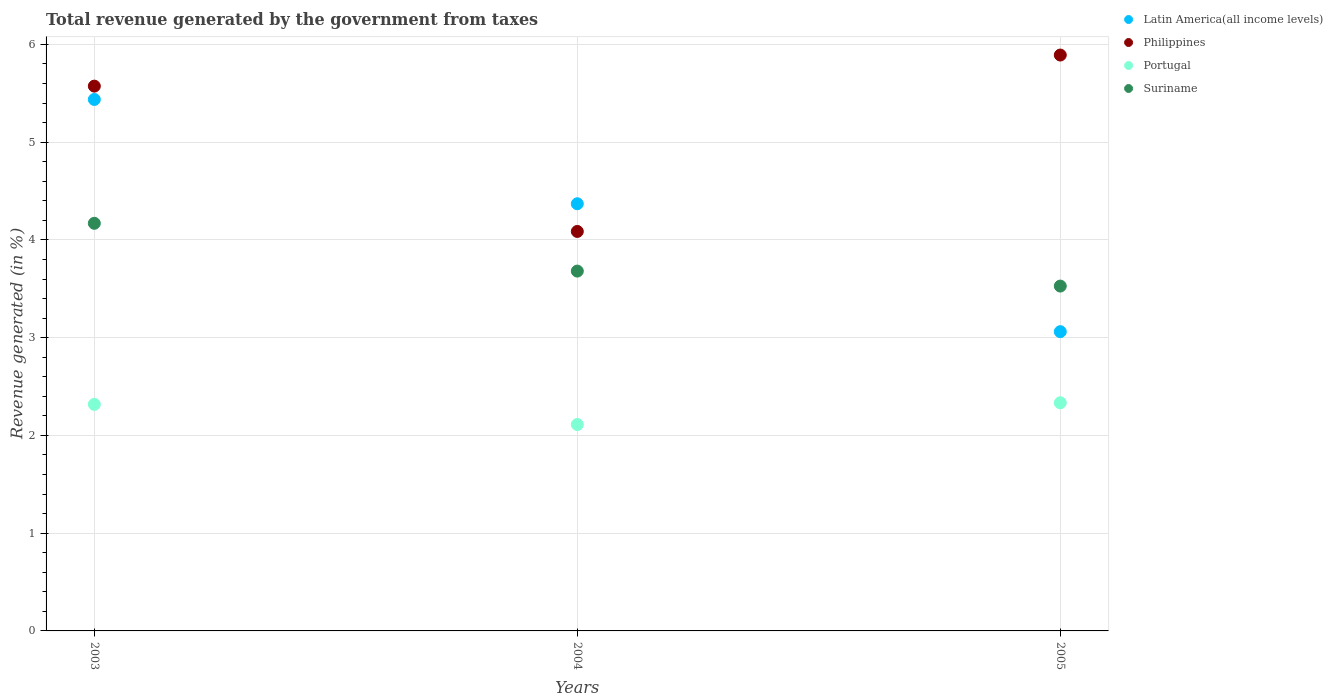What is the total revenue generated in Portugal in 2005?
Provide a succinct answer. 2.33. Across all years, what is the maximum total revenue generated in Suriname?
Ensure brevity in your answer.  4.17. Across all years, what is the minimum total revenue generated in Suriname?
Offer a very short reply. 3.53. What is the total total revenue generated in Portugal in the graph?
Your answer should be compact. 6.76. What is the difference between the total revenue generated in Portugal in 2003 and that in 2005?
Give a very brief answer. -0.02. What is the difference between the total revenue generated in Suriname in 2003 and the total revenue generated in Portugal in 2005?
Ensure brevity in your answer.  1.84. What is the average total revenue generated in Latin America(all income levels) per year?
Offer a very short reply. 4.29. In the year 2003, what is the difference between the total revenue generated in Suriname and total revenue generated in Portugal?
Make the answer very short. 1.85. In how many years, is the total revenue generated in Suriname greater than 0.6000000000000001 %?
Keep it short and to the point. 3. What is the ratio of the total revenue generated in Latin America(all income levels) in 2004 to that in 2005?
Your answer should be very brief. 1.43. Is the difference between the total revenue generated in Suriname in 2003 and 2005 greater than the difference between the total revenue generated in Portugal in 2003 and 2005?
Provide a succinct answer. Yes. What is the difference between the highest and the second highest total revenue generated in Portugal?
Your response must be concise. 0.02. What is the difference between the highest and the lowest total revenue generated in Suriname?
Ensure brevity in your answer.  0.64. In how many years, is the total revenue generated in Portugal greater than the average total revenue generated in Portugal taken over all years?
Offer a terse response. 2. Is the sum of the total revenue generated in Latin America(all income levels) in 2004 and 2005 greater than the maximum total revenue generated in Philippines across all years?
Provide a short and direct response. Yes. Does the total revenue generated in Portugal monotonically increase over the years?
Your response must be concise. No. Is the total revenue generated in Portugal strictly less than the total revenue generated in Latin America(all income levels) over the years?
Provide a succinct answer. Yes. How many dotlines are there?
Your answer should be compact. 4. How many years are there in the graph?
Provide a short and direct response. 3. What is the difference between two consecutive major ticks on the Y-axis?
Make the answer very short. 1. Where does the legend appear in the graph?
Your answer should be very brief. Top right. How are the legend labels stacked?
Your response must be concise. Vertical. What is the title of the graph?
Your response must be concise. Total revenue generated by the government from taxes. Does "Egypt, Arab Rep." appear as one of the legend labels in the graph?
Offer a terse response. No. What is the label or title of the Y-axis?
Make the answer very short. Revenue generated (in %). What is the Revenue generated (in %) of Latin America(all income levels) in 2003?
Provide a succinct answer. 5.44. What is the Revenue generated (in %) in Philippines in 2003?
Your response must be concise. 5.57. What is the Revenue generated (in %) of Portugal in 2003?
Your answer should be very brief. 2.32. What is the Revenue generated (in %) in Suriname in 2003?
Provide a succinct answer. 4.17. What is the Revenue generated (in %) in Latin America(all income levels) in 2004?
Offer a very short reply. 4.37. What is the Revenue generated (in %) in Philippines in 2004?
Your response must be concise. 4.09. What is the Revenue generated (in %) of Portugal in 2004?
Your answer should be very brief. 2.11. What is the Revenue generated (in %) of Suriname in 2004?
Ensure brevity in your answer.  3.68. What is the Revenue generated (in %) in Latin America(all income levels) in 2005?
Give a very brief answer. 3.06. What is the Revenue generated (in %) in Philippines in 2005?
Provide a succinct answer. 5.89. What is the Revenue generated (in %) in Portugal in 2005?
Ensure brevity in your answer.  2.33. What is the Revenue generated (in %) in Suriname in 2005?
Ensure brevity in your answer.  3.53. Across all years, what is the maximum Revenue generated (in %) of Latin America(all income levels)?
Offer a very short reply. 5.44. Across all years, what is the maximum Revenue generated (in %) of Philippines?
Provide a succinct answer. 5.89. Across all years, what is the maximum Revenue generated (in %) of Portugal?
Provide a short and direct response. 2.33. Across all years, what is the maximum Revenue generated (in %) of Suriname?
Provide a succinct answer. 4.17. Across all years, what is the minimum Revenue generated (in %) in Latin America(all income levels)?
Offer a terse response. 3.06. Across all years, what is the minimum Revenue generated (in %) of Philippines?
Ensure brevity in your answer.  4.09. Across all years, what is the minimum Revenue generated (in %) in Portugal?
Your answer should be very brief. 2.11. Across all years, what is the minimum Revenue generated (in %) of Suriname?
Your answer should be compact. 3.53. What is the total Revenue generated (in %) of Latin America(all income levels) in the graph?
Ensure brevity in your answer.  12.87. What is the total Revenue generated (in %) in Philippines in the graph?
Offer a very short reply. 15.55. What is the total Revenue generated (in %) in Portugal in the graph?
Your answer should be compact. 6.76. What is the total Revenue generated (in %) of Suriname in the graph?
Your answer should be compact. 11.38. What is the difference between the Revenue generated (in %) of Latin America(all income levels) in 2003 and that in 2004?
Offer a very short reply. 1.07. What is the difference between the Revenue generated (in %) of Philippines in 2003 and that in 2004?
Your answer should be very brief. 1.49. What is the difference between the Revenue generated (in %) in Portugal in 2003 and that in 2004?
Provide a short and direct response. 0.21. What is the difference between the Revenue generated (in %) in Suriname in 2003 and that in 2004?
Give a very brief answer. 0.49. What is the difference between the Revenue generated (in %) in Latin America(all income levels) in 2003 and that in 2005?
Make the answer very short. 2.38. What is the difference between the Revenue generated (in %) in Philippines in 2003 and that in 2005?
Provide a succinct answer. -0.32. What is the difference between the Revenue generated (in %) in Portugal in 2003 and that in 2005?
Provide a succinct answer. -0.02. What is the difference between the Revenue generated (in %) of Suriname in 2003 and that in 2005?
Provide a succinct answer. 0.64. What is the difference between the Revenue generated (in %) of Latin America(all income levels) in 2004 and that in 2005?
Provide a succinct answer. 1.31. What is the difference between the Revenue generated (in %) of Philippines in 2004 and that in 2005?
Make the answer very short. -1.8. What is the difference between the Revenue generated (in %) in Portugal in 2004 and that in 2005?
Provide a succinct answer. -0.22. What is the difference between the Revenue generated (in %) in Suriname in 2004 and that in 2005?
Offer a very short reply. 0.15. What is the difference between the Revenue generated (in %) in Latin America(all income levels) in 2003 and the Revenue generated (in %) in Philippines in 2004?
Your answer should be compact. 1.35. What is the difference between the Revenue generated (in %) in Latin America(all income levels) in 2003 and the Revenue generated (in %) in Portugal in 2004?
Keep it short and to the point. 3.33. What is the difference between the Revenue generated (in %) of Latin America(all income levels) in 2003 and the Revenue generated (in %) of Suriname in 2004?
Your answer should be very brief. 1.76. What is the difference between the Revenue generated (in %) in Philippines in 2003 and the Revenue generated (in %) in Portugal in 2004?
Keep it short and to the point. 3.46. What is the difference between the Revenue generated (in %) in Philippines in 2003 and the Revenue generated (in %) in Suriname in 2004?
Ensure brevity in your answer.  1.89. What is the difference between the Revenue generated (in %) of Portugal in 2003 and the Revenue generated (in %) of Suriname in 2004?
Make the answer very short. -1.36. What is the difference between the Revenue generated (in %) of Latin America(all income levels) in 2003 and the Revenue generated (in %) of Philippines in 2005?
Offer a terse response. -0.45. What is the difference between the Revenue generated (in %) of Latin America(all income levels) in 2003 and the Revenue generated (in %) of Portugal in 2005?
Your answer should be compact. 3.1. What is the difference between the Revenue generated (in %) of Latin America(all income levels) in 2003 and the Revenue generated (in %) of Suriname in 2005?
Your answer should be very brief. 1.91. What is the difference between the Revenue generated (in %) of Philippines in 2003 and the Revenue generated (in %) of Portugal in 2005?
Offer a very short reply. 3.24. What is the difference between the Revenue generated (in %) in Philippines in 2003 and the Revenue generated (in %) in Suriname in 2005?
Make the answer very short. 2.05. What is the difference between the Revenue generated (in %) of Portugal in 2003 and the Revenue generated (in %) of Suriname in 2005?
Offer a terse response. -1.21. What is the difference between the Revenue generated (in %) of Latin America(all income levels) in 2004 and the Revenue generated (in %) of Philippines in 2005?
Offer a very short reply. -1.52. What is the difference between the Revenue generated (in %) in Latin America(all income levels) in 2004 and the Revenue generated (in %) in Portugal in 2005?
Your answer should be compact. 2.04. What is the difference between the Revenue generated (in %) in Latin America(all income levels) in 2004 and the Revenue generated (in %) in Suriname in 2005?
Make the answer very short. 0.84. What is the difference between the Revenue generated (in %) in Philippines in 2004 and the Revenue generated (in %) in Portugal in 2005?
Provide a succinct answer. 1.75. What is the difference between the Revenue generated (in %) of Philippines in 2004 and the Revenue generated (in %) of Suriname in 2005?
Ensure brevity in your answer.  0.56. What is the difference between the Revenue generated (in %) in Portugal in 2004 and the Revenue generated (in %) in Suriname in 2005?
Give a very brief answer. -1.42. What is the average Revenue generated (in %) of Latin America(all income levels) per year?
Your answer should be very brief. 4.29. What is the average Revenue generated (in %) in Philippines per year?
Your answer should be very brief. 5.18. What is the average Revenue generated (in %) of Portugal per year?
Provide a succinct answer. 2.25. What is the average Revenue generated (in %) of Suriname per year?
Offer a very short reply. 3.79. In the year 2003, what is the difference between the Revenue generated (in %) in Latin America(all income levels) and Revenue generated (in %) in Philippines?
Ensure brevity in your answer.  -0.14. In the year 2003, what is the difference between the Revenue generated (in %) of Latin America(all income levels) and Revenue generated (in %) of Portugal?
Your response must be concise. 3.12. In the year 2003, what is the difference between the Revenue generated (in %) of Latin America(all income levels) and Revenue generated (in %) of Suriname?
Your answer should be very brief. 1.27. In the year 2003, what is the difference between the Revenue generated (in %) of Philippines and Revenue generated (in %) of Portugal?
Offer a very short reply. 3.26. In the year 2003, what is the difference between the Revenue generated (in %) of Philippines and Revenue generated (in %) of Suriname?
Your answer should be very brief. 1.4. In the year 2003, what is the difference between the Revenue generated (in %) in Portugal and Revenue generated (in %) in Suriname?
Offer a very short reply. -1.85. In the year 2004, what is the difference between the Revenue generated (in %) of Latin America(all income levels) and Revenue generated (in %) of Philippines?
Your answer should be compact. 0.28. In the year 2004, what is the difference between the Revenue generated (in %) in Latin America(all income levels) and Revenue generated (in %) in Portugal?
Your answer should be compact. 2.26. In the year 2004, what is the difference between the Revenue generated (in %) of Latin America(all income levels) and Revenue generated (in %) of Suriname?
Make the answer very short. 0.69. In the year 2004, what is the difference between the Revenue generated (in %) of Philippines and Revenue generated (in %) of Portugal?
Keep it short and to the point. 1.98. In the year 2004, what is the difference between the Revenue generated (in %) in Philippines and Revenue generated (in %) in Suriname?
Your answer should be very brief. 0.41. In the year 2004, what is the difference between the Revenue generated (in %) in Portugal and Revenue generated (in %) in Suriname?
Offer a terse response. -1.57. In the year 2005, what is the difference between the Revenue generated (in %) of Latin America(all income levels) and Revenue generated (in %) of Philippines?
Keep it short and to the point. -2.83. In the year 2005, what is the difference between the Revenue generated (in %) of Latin America(all income levels) and Revenue generated (in %) of Portugal?
Your answer should be compact. 0.73. In the year 2005, what is the difference between the Revenue generated (in %) of Latin America(all income levels) and Revenue generated (in %) of Suriname?
Offer a terse response. -0.47. In the year 2005, what is the difference between the Revenue generated (in %) of Philippines and Revenue generated (in %) of Portugal?
Provide a succinct answer. 3.56. In the year 2005, what is the difference between the Revenue generated (in %) of Philippines and Revenue generated (in %) of Suriname?
Make the answer very short. 2.36. In the year 2005, what is the difference between the Revenue generated (in %) of Portugal and Revenue generated (in %) of Suriname?
Make the answer very short. -1.19. What is the ratio of the Revenue generated (in %) of Latin America(all income levels) in 2003 to that in 2004?
Your response must be concise. 1.24. What is the ratio of the Revenue generated (in %) in Philippines in 2003 to that in 2004?
Offer a terse response. 1.36. What is the ratio of the Revenue generated (in %) in Portugal in 2003 to that in 2004?
Provide a succinct answer. 1.1. What is the ratio of the Revenue generated (in %) of Suriname in 2003 to that in 2004?
Provide a succinct answer. 1.13. What is the ratio of the Revenue generated (in %) of Latin America(all income levels) in 2003 to that in 2005?
Make the answer very short. 1.78. What is the ratio of the Revenue generated (in %) in Philippines in 2003 to that in 2005?
Offer a terse response. 0.95. What is the ratio of the Revenue generated (in %) in Portugal in 2003 to that in 2005?
Give a very brief answer. 0.99. What is the ratio of the Revenue generated (in %) in Suriname in 2003 to that in 2005?
Your answer should be compact. 1.18. What is the ratio of the Revenue generated (in %) in Latin America(all income levels) in 2004 to that in 2005?
Offer a terse response. 1.43. What is the ratio of the Revenue generated (in %) of Philippines in 2004 to that in 2005?
Offer a very short reply. 0.69. What is the ratio of the Revenue generated (in %) in Portugal in 2004 to that in 2005?
Make the answer very short. 0.9. What is the ratio of the Revenue generated (in %) of Suriname in 2004 to that in 2005?
Offer a terse response. 1.04. What is the difference between the highest and the second highest Revenue generated (in %) of Latin America(all income levels)?
Make the answer very short. 1.07. What is the difference between the highest and the second highest Revenue generated (in %) in Philippines?
Ensure brevity in your answer.  0.32. What is the difference between the highest and the second highest Revenue generated (in %) in Portugal?
Ensure brevity in your answer.  0.02. What is the difference between the highest and the second highest Revenue generated (in %) in Suriname?
Offer a terse response. 0.49. What is the difference between the highest and the lowest Revenue generated (in %) in Latin America(all income levels)?
Provide a succinct answer. 2.38. What is the difference between the highest and the lowest Revenue generated (in %) in Philippines?
Make the answer very short. 1.8. What is the difference between the highest and the lowest Revenue generated (in %) of Portugal?
Keep it short and to the point. 0.22. What is the difference between the highest and the lowest Revenue generated (in %) of Suriname?
Provide a short and direct response. 0.64. 